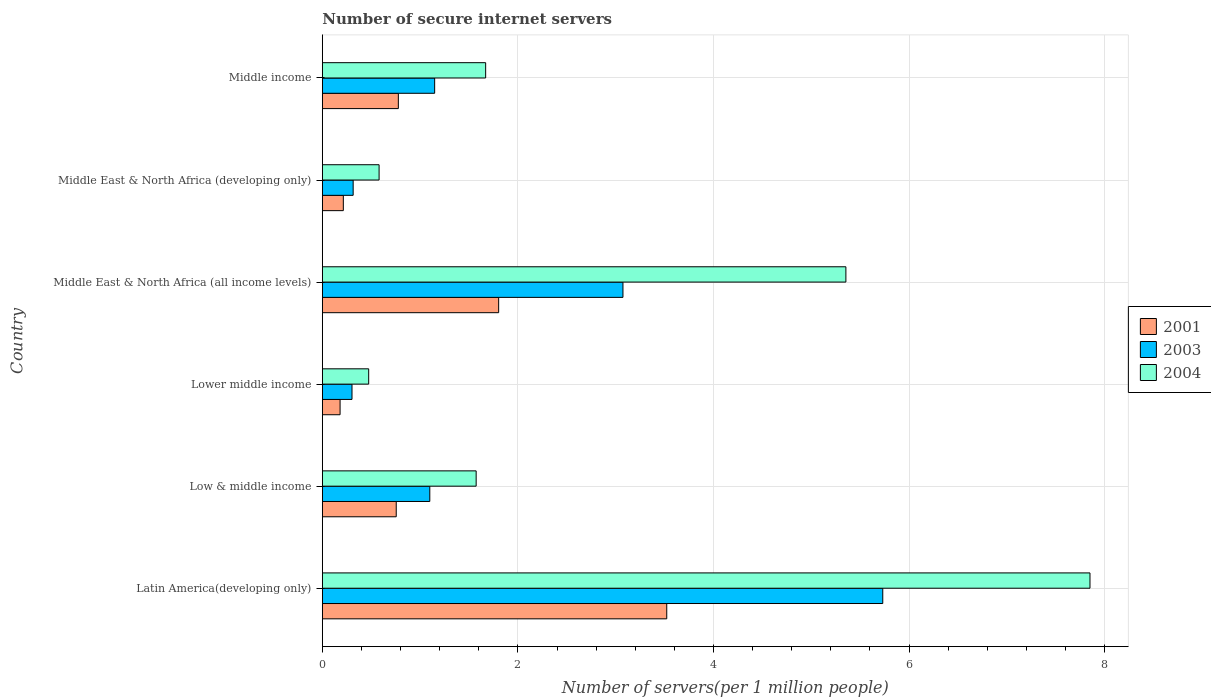How many different coloured bars are there?
Provide a short and direct response. 3. How many groups of bars are there?
Provide a short and direct response. 6. Are the number of bars on each tick of the Y-axis equal?
Offer a terse response. Yes. How many bars are there on the 6th tick from the top?
Provide a short and direct response. 3. How many bars are there on the 5th tick from the bottom?
Provide a short and direct response. 3. What is the label of the 3rd group of bars from the top?
Provide a succinct answer. Middle East & North Africa (all income levels). What is the number of secure internet servers in 2001 in Middle income?
Offer a very short reply. 0.78. Across all countries, what is the maximum number of secure internet servers in 2003?
Provide a succinct answer. 5.73. Across all countries, what is the minimum number of secure internet servers in 2004?
Make the answer very short. 0.47. In which country was the number of secure internet servers in 2001 maximum?
Provide a short and direct response. Latin America(developing only). In which country was the number of secure internet servers in 2004 minimum?
Offer a terse response. Lower middle income. What is the total number of secure internet servers in 2001 in the graph?
Offer a terse response. 7.25. What is the difference between the number of secure internet servers in 2003 in Latin America(developing only) and that in Lower middle income?
Offer a very short reply. 5.43. What is the difference between the number of secure internet servers in 2003 in Middle income and the number of secure internet servers in 2001 in Lower middle income?
Your answer should be very brief. 0.97. What is the average number of secure internet servers in 2004 per country?
Provide a succinct answer. 2.92. What is the difference between the number of secure internet servers in 2004 and number of secure internet servers in 2003 in Middle income?
Offer a very short reply. 0.52. What is the ratio of the number of secure internet servers in 2004 in Latin America(developing only) to that in Middle East & North Africa (developing only)?
Provide a short and direct response. 13.52. Is the number of secure internet servers in 2003 in Middle East & North Africa (all income levels) less than that in Middle income?
Make the answer very short. No. Is the difference between the number of secure internet servers in 2004 in Low & middle income and Middle East & North Africa (developing only) greater than the difference between the number of secure internet servers in 2003 in Low & middle income and Middle East & North Africa (developing only)?
Make the answer very short. Yes. What is the difference between the highest and the second highest number of secure internet servers in 2003?
Your answer should be very brief. 2.66. What is the difference between the highest and the lowest number of secure internet servers in 2001?
Your response must be concise. 3.34. In how many countries, is the number of secure internet servers in 2004 greater than the average number of secure internet servers in 2004 taken over all countries?
Make the answer very short. 2. What does the 2nd bar from the top in Middle East & North Africa (developing only) represents?
Provide a short and direct response. 2003. Is it the case that in every country, the sum of the number of secure internet servers in 2003 and number of secure internet servers in 2001 is greater than the number of secure internet servers in 2004?
Your answer should be compact. No. How many bars are there?
Make the answer very short. 18. What is the difference between two consecutive major ticks on the X-axis?
Your answer should be compact. 2. Does the graph contain any zero values?
Your response must be concise. No. Does the graph contain grids?
Your answer should be compact. Yes. How many legend labels are there?
Your response must be concise. 3. How are the legend labels stacked?
Your response must be concise. Vertical. What is the title of the graph?
Give a very brief answer. Number of secure internet servers. Does "1964" appear as one of the legend labels in the graph?
Give a very brief answer. No. What is the label or title of the X-axis?
Give a very brief answer. Number of servers(per 1 million people). What is the label or title of the Y-axis?
Provide a short and direct response. Country. What is the Number of servers(per 1 million people) in 2001 in Latin America(developing only)?
Make the answer very short. 3.52. What is the Number of servers(per 1 million people) of 2003 in Latin America(developing only)?
Provide a succinct answer. 5.73. What is the Number of servers(per 1 million people) of 2004 in Latin America(developing only)?
Offer a very short reply. 7.85. What is the Number of servers(per 1 million people) in 2001 in Low & middle income?
Keep it short and to the point. 0.76. What is the Number of servers(per 1 million people) in 2003 in Low & middle income?
Give a very brief answer. 1.1. What is the Number of servers(per 1 million people) in 2004 in Low & middle income?
Offer a very short reply. 1.57. What is the Number of servers(per 1 million people) in 2001 in Lower middle income?
Provide a succinct answer. 0.18. What is the Number of servers(per 1 million people) of 2003 in Lower middle income?
Provide a succinct answer. 0.3. What is the Number of servers(per 1 million people) of 2004 in Lower middle income?
Keep it short and to the point. 0.47. What is the Number of servers(per 1 million people) in 2001 in Middle East & North Africa (all income levels)?
Provide a short and direct response. 1.8. What is the Number of servers(per 1 million people) of 2003 in Middle East & North Africa (all income levels)?
Offer a very short reply. 3.07. What is the Number of servers(per 1 million people) of 2004 in Middle East & North Africa (all income levels)?
Ensure brevity in your answer.  5.35. What is the Number of servers(per 1 million people) in 2001 in Middle East & North Africa (developing only)?
Your response must be concise. 0.21. What is the Number of servers(per 1 million people) in 2003 in Middle East & North Africa (developing only)?
Offer a very short reply. 0.32. What is the Number of servers(per 1 million people) of 2004 in Middle East & North Africa (developing only)?
Your answer should be very brief. 0.58. What is the Number of servers(per 1 million people) in 2001 in Middle income?
Make the answer very short. 0.78. What is the Number of servers(per 1 million people) in 2003 in Middle income?
Ensure brevity in your answer.  1.15. What is the Number of servers(per 1 million people) in 2004 in Middle income?
Offer a terse response. 1.67. Across all countries, what is the maximum Number of servers(per 1 million people) in 2001?
Provide a succinct answer. 3.52. Across all countries, what is the maximum Number of servers(per 1 million people) of 2003?
Your answer should be compact. 5.73. Across all countries, what is the maximum Number of servers(per 1 million people) in 2004?
Your answer should be very brief. 7.85. Across all countries, what is the minimum Number of servers(per 1 million people) of 2001?
Give a very brief answer. 0.18. Across all countries, what is the minimum Number of servers(per 1 million people) of 2003?
Provide a short and direct response. 0.3. Across all countries, what is the minimum Number of servers(per 1 million people) of 2004?
Give a very brief answer. 0.47. What is the total Number of servers(per 1 million people) of 2001 in the graph?
Provide a short and direct response. 7.25. What is the total Number of servers(per 1 million people) in 2003 in the graph?
Offer a very short reply. 11.67. What is the total Number of servers(per 1 million people) of 2004 in the graph?
Your answer should be very brief. 17.5. What is the difference between the Number of servers(per 1 million people) in 2001 in Latin America(developing only) and that in Low & middle income?
Ensure brevity in your answer.  2.77. What is the difference between the Number of servers(per 1 million people) in 2003 in Latin America(developing only) and that in Low & middle income?
Your response must be concise. 4.63. What is the difference between the Number of servers(per 1 million people) in 2004 in Latin America(developing only) and that in Low & middle income?
Give a very brief answer. 6.28. What is the difference between the Number of servers(per 1 million people) of 2001 in Latin America(developing only) and that in Lower middle income?
Provide a succinct answer. 3.34. What is the difference between the Number of servers(per 1 million people) of 2003 in Latin America(developing only) and that in Lower middle income?
Provide a short and direct response. 5.43. What is the difference between the Number of servers(per 1 million people) in 2004 in Latin America(developing only) and that in Lower middle income?
Provide a short and direct response. 7.38. What is the difference between the Number of servers(per 1 million people) in 2001 in Latin America(developing only) and that in Middle East & North Africa (all income levels)?
Your answer should be very brief. 1.72. What is the difference between the Number of servers(per 1 million people) of 2003 in Latin America(developing only) and that in Middle East & North Africa (all income levels)?
Give a very brief answer. 2.66. What is the difference between the Number of servers(per 1 million people) of 2004 in Latin America(developing only) and that in Middle East & North Africa (all income levels)?
Ensure brevity in your answer.  2.5. What is the difference between the Number of servers(per 1 million people) of 2001 in Latin America(developing only) and that in Middle East & North Africa (developing only)?
Ensure brevity in your answer.  3.31. What is the difference between the Number of servers(per 1 million people) of 2003 in Latin America(developing only) and that in Middle East & North Africa (developing only)?
Keep it short and to the point. 5.42. What is the difference between the Number of servers(per 1 million people) of 2004 in Latin America(developing only) and that in Middle East & North Africa (developing only)?
Offer a terse response. 7.27. What is the difference between the Number of servers(per 1 million people) in 2001 in Latin America(developing only) and that in Middle income?
Offer a very short reply. 2.75. What is the difference between the Number of servers(per 1 million people) of 2003 in Latin America(developing only) and that in Middle income?
Your answer should be very brief. 4.58. What is the difference between the Number of servers(per 1 million people) of 2004 in Latin America(developing only) and that in Middle income?
Your answer should be very brief. 6.18. What is the difference between the Number of servers(per 1 million people) in 2001 in Low & middle income and that in Lower middle income?
Your answer should be very brief. 0.57. What is the difference between the Number of servers(per 1 million people) of 2003 in Low & middle income and that in Lower middle income?
Ensure brevity in your answer.  0.8. What is the difference between the Number of servers(per 1 million people) in 2004 in Low & middle income and that in Lower middle income?
Ensure brevity in your answer.  1.1. What is the difference between the Number of servers(per 1 million people) of 2001 in Low & middle income and that in Middle East & North Africa (all income levels)?
Your answer should be very brief. -1.05. What is the difference between the Number of servers(per 1 million people) in 2003 in Low & middle income and that in Middle East & North Africa (all income levels)?
Ensure brevity in your answer.  -1.98. What is the difference between the Number of servers(per 1 million people) in 2004 in Low & middle income and that in Middle East & North Africa (all income levels)?
Provide a succinct answer. -3.78. What is the difference between the Number of servers(per 1 million people) of 2001 in Low & middle income and that in Middle East & North Africa (developing only)?
Ensure brevity in your answer.  0.54. What is the difference between the Number of servers(per 1 million people) in 2003 in Low & middle income and that in Middle East & North Africa (developing only)?
Provide a succinct answer. 0.78. What is the difference between the Number of servers(per 1 million people) in 2001 in Low & middle income and that in Middle income?
Ensure brevity in your answer.  -0.02. What is the difference between the Number of servers(per 1 million people) in 2003 in Low & middle income and that in Middle income?
Make the answer very short. -0.05. What is the difference between the Number of servers(per 1 million people) of 2004 in Low & middle income and that in Middle income?
Provide a short and direct response. -0.1. What is the difference between the Number of servers(per 1 million people) of 2001 in Lower middle income and that in Middle East & North Africa (all income levels)?
Offer a very short reply. -1.62. What is the difference between the Number of servers(per 1 million people) of 2003 in Lower middle income and that in Middle East & North Africa (all income levels)?
Offer a very short reply. -2.77. What is the difference between the Number of servers(per 1 million people) in 2004 in Lower middle income and that in Middle East & North Africa (all income levels)?
Ensure brevity in your answer.  -4.88. What is the difference between the Number of servers(per 1 million people) in 2001 in Lower middle income and that in Middle East & North Africa (developing only)?
Provide a short and direct response. -0.03. What is the difference between the Number of servers(per 1 million people) of 2003 in Lower middle income and that in Middle East & North Africa (developing only)?
Offer a very short reply. -0.01. What is the difference between the Number of servers(per 1 million people) of 2004 in Lower middle income and that in Middle East & North Africa (developing only)?
Make the answer very short. -0.11. What is the difference between the Number of servers(per 1 million people) of 2001 in Lower middle income and that in Middle income?
Offer a terse response. -0.6. What is the difference between the Number of servers(per 1 million people) in 2003 in Lower middle income and that in Middle income?
Offer a very short reply. -0.85. What is the difference between the Number of servers(per 1 million people) in 2004 in Lower middle income and that in Middle income?
Your response must be concise. -1.2. What is the difference between the Number of servers(per 1 million people) of 2001 in Middle East & North Africa (all income levels) and that in Middle East & North Africa (developing only)?
Your answer should be very brief. 1.59. What is the difference between the Number of servers(per 1 million people) of 2003 in Middle East & North Africa (all income levels) and that in Middle East & North Africa (developing only)?
Your response must be concise. 2.76. What is the difference between the Number of servers(per 1 million people) of 2004 in Middle East & North Africa (all income levels) and that in Middle East & North Africa (developing only)?
Provide a short and direct response. 4.77. What is the difference between the Number of servers(per 1 million people) of 2001 in Middle East & North Africa (all income levels) and that in Middle income?
Your response must be concise. 1.03. What is the difference between the Number of servers(per 1 million people) in 2003 in Middle East & North Africa (all income levels) and that in Middle income?
Offer a terse response. 1.93. What is the difference between the Number of servers(per 1 million people) in 2004 in Middle East & North Africa (all income levels) and that in Middle income?
Your response must be concise. 3.68. What is the difference between the Number of servers(per 1 million people) of 2001 in Middle East & North Africa (developing only) and that in Middle income?
Make the answer very short. -0.56. What is the difference between the Number of servers(per 1 million people) of 2003 in Middle East & North Africa (developing only) and that in Middle income?
Keep it short and to the point. -0.83. What is the difference between the Number of servers(per 1 million people) of 2004 in Middle East & North Africa (developing only) and that in Middle income?
Ensure brevity in your answer.  -1.09. What is the difference between the Number of servers(per 1 million people) in 2001 in Latin America(developing only) and the Number of servers(per 1 million people) in 2003 in Low & middle income?
Your answer should be very brief. 2.42. What is the difference between the Number of servers(per 1 million people) of 2001 in Latin America(developing only) and the Number of servers(per 1 million people) of 2004 in Low & middle income?
Give a very brief answer. 1.95. What is the difference between the Number of servers(per 1 million people) of 2003 in Latin America(developing only) and the Number of servers(per 1 million people) of 2004 in Low & middle income?
Make the answer very short. 4.16. What is the difference between the Number of servers(per 1 million people) in 2001 in Latin America(developing only) and the Number of servers(per 1 million people) in 2003 in Lower middle income?
Your answer should be very brief. 3.22. What is the difference between the Number of servers(per 1 million people) of 2001 in Latin America(developing only) and the Number of servers(per 1 million people) of 2004 in Lower middle income?
Provide a short and direct response. 3.05. What is the difference between the Number of servers(per 1 million people) of 2003 in Latin America(developing only) and the Number of servers(per 1 million people) of 2004 in Lower middle income?
Ensure brevity in your answer.  5.26. What is the difference between the Number of servers(per 1 million people) in 2001 in Latin America(developing only) and the Number of servers(per 1 million people) in 2003 in Middle East & North Africa (all income levels)?
Your answer should be very brief. 0.45. What is the difference between the Number of servers(per 1 million people) of 2001 in Latin America(developing only) and the Number of servers(per 1 million people) of 2004 in Middle East & North Africa (all income levels)?
Keep it short and to the point. -1.83. What is the difference between the Number of servers(per 1 million people) in 2003 in Latin America(developing only) and the Number of servers(per 1 million people) in 2004 in Middle East & North Africa (all income levels)?
Your answer should be very brief. 0.38. What is the difference between the Number of servers(per 1 million people) in 2001 in Latin America(developing only) and the Number of servers(per 1 million people) in 2003 in Middle East & North Africa (developing only)?
Offer a terse response. 3.21. What is the difference between the Number of servers(per 1 million people) of 2001 in Latin America(developing only) and the Number of servers(per 1 million people) of 2004 in Middle East & North Africa (developing only)?
Provide a succinct answer. 2.94. What is the difference between the Number of servers(per 1 million people) of 2003 in Latin America(developing only) and the Number of servers(per 1 million people) of 2004 in Middle East & North Africa (developing only)?
Keep it short and to the point. 5.15. What is the difference between the Number of servers(per 1 million people) in 2001 in Latin America(developing only) and the Number of servers(per 1 million people) in 2003 in Middle income?
Your answer should be compact. 2.37. What is the difference between the Number of servers(per 1 million people) of 2001 in Latin America(developing only) and the Number of servers(per 1 million people) of 2004 in Middle income?
Offer a very short reply. 1.85. What is the difference between the Number of servers(per 1 million people) of 2003 in Latin America(developing only) and the Number of servers(per 1 million people) of 2004 in Middle income?
Your answer should be compact. 4.06. What is the difference between the Number of servers(per 1 million people) in 2001 in Low & middle income and the Number of servers(per 1 million people) in 2003 in Lower middle income?
Keep it short and to the point. 0.45. What is the difference between the Number of servers(per 1 million people) of 2001 in Low & middle income and the Number of servers(per 1 million people) of 2004 in Lower middle income?
Offer a terse response. 0.28. What is the difference between the Number of servers(per 1 million people) in 2003 in Low & middle income and the Number of servers(per 1 million people) in 2004 in Lower middle income?
Your response must be concise. 0.62. What is the difference between the Number of servers(per 1 million people) in 2001 in Low & middle income and the Number of servers(per 1 million people) in 2003 in Middle East & North Africa (all income levels)?
Keep it short and to the point. -2.32. What is the difference between the Number of servers(per 1 million people) of 2001 in Low & middle income and the Number of servers(per 1 million people) of 2004 in Middle East & North Africa (all income levels)?
Ensure brevity in your answer.  -4.6. What is the difference between the Number of servers(per 1 million people) in 2003 in Low & middle income and the Number of servers(per 1 million people) in 2004 in Middle East & North Africa (all income levels)?
Your answer should be compact. -4.26. What is the difference between the Number of servers(per 1 million people) in 2001 in Low & middle income and the Number of servers(per 1 million people) in 2003 in Middle East & North Africa (developing only)?
Your response must be concise. 0.44. What is the difference between the Number of servers(per 1 million people) of 2001 in Low & middle income and the Number of servers(per 1 million people) of 2004 in Middle East & North Africa (developing only)?
Offer a terse response. 0.18. What is the difference between the Number of servers(per 1 million people) in 2003 in Low & middle income and the Number of servers(per 1 million people) in 2004 in Middle East & North Africa (developing only)?
Your answer should be very brief. 0.52. What is the difference between the Number of servers(per 1 million people) in 2001 in Low & middle income and the Number of servers(per 1 million people) in 2003 in Middle income?
Keep it short and to the point. -0.39. What is the difference between the Number of servers(per 1 million people) in 2001 in Low & middle income and the Number of servers(per 1 million people) in 2004 in Middle income?
Offer a very short reply. -0.91. What is the difference between the Number of servers(per 1 million people) of 2003 in Low & middle income and the Number of servers(per 1 million people) of 2004 in Middle income?
Offer a very short reply. -0.57. What is the difference between the Number of servers(per 1 million people) in 2001 in Lower middle income and the Number of servers(per 1 million people) in 2003 in Middle East & North Africa (all income levels)?
Give a very brief answer. -2.89. What is the difference between the Number of servers(per 1 million people) in 2001 in Lower middle income and the Number of servers(per 1 million people) in 2004 in Middle East & North Africa (all income levels)?
Ensure brevity in your answer.  -5.17. What is the difference between the Number of servers(per 1 million people) in 2003 in Lower middle income and the Number of servers(per 1 million people) in 2004 in Middle East & North Africa (all income levels)?
Offer a terse response. -5.05. What is the difference between the Number of servers(per 1 million people) in 2001 in Lower middle income and the Number of servers(per 1 million people) in 2003 in Middle East & North Africa (developing only)?
Offer a terse response. -0.13. What is the difference between the Number of servers(per 1 million people) of 2001 in Lower middle income and the Number of servers(per 1 million people) of 2004 in Middle East & North Africa (developing only)?
Your answer should be very brief. -0.4. What is the difference between the Number of servers(per 1 million people) in 2003 in Lower middle income and the Number of servers(per 1 million people) in 2004 in Middle East & North Africa (developing only)?
Ensure brevity in your answer.  -0.28. What is the difference between the Number of servers(per 1 million people) of 2001 in Lower middle income and the Number of servers(per 1 million people) of 2003 in Middle income?
Keep it short and to the point. -0.97. What is the difference between the Number of servers(per 1 million people) in 2001 in Lower middle income and the Number of servers(per 1 million people) in 2004 in Middle income?
Ensure brevity in your answer.  -1.49. What is the difference between the Number of servers(per 1 million people) of 2003 in Lower middle income and the Number of servers(per 1 million people) of 2004 in Middle income?
Give a very brief answer. -1.37. What is the difference between the Number of servers(per 1 million people) in 2001 in Middle East & North Africa (all income levels) and the Number of servers(per 1 million people) in 2003 in Middle East & North Africa (developing only)?
Offer a terse response. 1.49. What is the difference between the Number of servers(per 1 million people) in 2001 in Middle East & North Africa (all income levels) and the Number of servers(per 1 million people) in 2004 in Middle East & North Africa (developing only)?
Provide a short and direct response. 1.22. What is the difference between the Number of servers(per 1 million people) of 2003 in Middle East & North Africa (all income levels) and the Number of servers(per 1 million people) of 2004 in Middle East & North Africa (developing only)?
Offer a very short reply. 2.49. What is the difference between the Number of servers(per 1 million people) of 2001 in Middle East & North Africa (all income levels) and the Number of servers(per 1 million people) of 2003 in Middle income?
Offer a very short reply. 0.65. What is the difference between the Number of servers(per 1 million people) of 2001 in Middle East & North Africa (all income levels) and the Number of servers(per 1 million people) of 2004 in Middle income?
Keep it short and to the point. 0.13. What is the difference between the Number of servers(per 1 million people) of 2003 in Middle East & North Africa (all income levels) and the Number of servers(per 1 million people) of 2004 in Middle income?
Your answer should be very brief. 1.4. What is the difference between the Number of servers(per 1 million people) of 2001 in Middle East & North Africa (developing only) and the Number of servers(per 1 million people) of 2003 in Middle income?
Keep it short and to the point. -0.93. What is the difference between the Number of servers(per 1 million people) in 2001 in Middle East & North Africa (developing only) and the Number of servers(per 1 million people) in 2004 in Middle income?
Your answer should be compact. -1.46. What is the difference between the Number of servers(per 1 million people) of 2003 in Middle East & North Africa (developing only) and the Number of servers(per 1 million people) of 2004 in Middle income?
Ensure brevity in your answer.  -1.35. What is the average Number of servers(per 1 million people) of 2001 per country?
Offer a terse response. 1.21. What is the average Number of servers(per 1 million people) in 2003 per country?
Your answer should be very brief. 1.95. What is the average Number of servers(per 1 million people) in 2004 per country?
Your answer should be very brief. 2.92. What is the difference between the Number of servers(per 1 million people) in 2001 and Number of servers(per 1 million people) in 2003 in Latin America(developing only)?
Give a very brief answer. -2.21. What is the difference between the Number of servers(per 1 million people) in 2001 and Number of servers(per 1 million people) in 2004 in Latin America(developing only)?
Provide a short and direct response. -4.33. What is the difference between the Number of servers(per 1 million people) in 2003 and Number of servers(per 1 million people) in 2004 in Latin America(developing only)?
Make the answer very short. -2.12. What is the difference between the Number of servers(per 1 million people) of 2001 and Number of servers(per 1 million people) of 2003 in Low & middle income?
Offer a terse response. -0.34. What is the difference between the Number of servers(per 1 million people) in 2001 and Number of servers(per 1 million people) in 2004 in Low & middle income?
Give a very brief answer. -0.82. What is the difference between the Number of servers(per 1 million people) in 2003 and Number of servers(per 1 million people) in 2004 in Low & middle income?
Provide a short and direct response. -0.47. What is the difference between the Number of servers(per 1 million people) of 2001 and Number of servers(per 1 million people) of 2003 in Lower middle income?
Offer a very short reply. -0.12. What is the difference between the Number of servers(per 1 million people) in 2001 and Number of servers(per 1 million people) in 2004 in Lower middle income?
Offer a terse response. -0.29. What is the difference between the Number of servers(per 1 million people) in 2003 and Number of servers(per 1 million people) in 2004 in Lower middle income?
Offer a terse response. -0.17. What is the difference between the Number of servers(per 1 million people) of 2001 and Number of servers(per 1 million people) of 2003 in Middle East & North Africa (all income levels)?
Offer a very short reply. -1.27. What is the difference between the Number of servers(per 1 million people) of 2001 and Number of servers(per 1 million people) of 2004 in Middle East & North Africa (all income levels)?
Offer a very short reply. -3.55. What is the difference between the Number of servers(per 1 million people) in 2003 and Number of servers(per 1 million people) in 2004 in Middle East & North Africa (all income levels)?
Ensure brevity in your answer.  -2.28. What is the difference between the Number of servers(per 1 million people) in 2001 and Number of servers(per 1 million people) in 2003 in Middle East & North Africa (developing only)?
Offer a terse response. -0.1. What is the difference between the Number of servers(per 1 million people) of 2001 and Number of servers(per 1 million people) of 2004 in Middle East & North Africa (developing only)?
Give a very brief answer. -0.37. What is the difference between the Number of servers(per 1 million people) in 2003 and Number of servers(per 1 million people) in 2004 in Middle East & North Africa (developing only)?
Give a very brief answer. -0.27. What is the difference between the Number of servers(per 1 million people) in 2001 and Number of servers(per 1 million people) in 2003 in Middle income?
Your response must be concise. -0.37. What is the difference between the Number of servers(per 1 million people) of 2001 and Number of servers(per 1 million people) of 2004 in Middle income?
Your response must be concise. -0.89. What is the difference between the Number of servers(per 1 million people) in 2003 and Number of servers(per 1 million people) in 2004 in Middle income?
Provide a succinct answer. -0.52. What is the ratio of the Number of servers(per 1 million people) in 2001 in Latin America(developing only) to that in Low & middle income?
Your answer should be compact. 4.66. What is the ratio of the Number of servers(per 1 million people) of 2003 in Latin America(developing only) to that in Low & middle income?
Offer a very short reply. 5.21. What is the ratio of the Number of servers(per 1 million people) in 2004 in Latin America(developing only) to that in Low & middle income?
Give a very brief answer. 4.99. What is the ratio of the Number of servers(per 1 million people) of 2001 in Latin America(developing only) to that in Lower middle income?
Your answer should be very brief. 19.4. What is the ratio of the Number of servers(per 1 million people) in 2003 in Latin America(developing only) to that in Lower middle income?
Provide a short and direct response. 18.89. What is the ratio of the Number of servers(per 1 million people) of 2004 in Latin America(developing only) to that in Lower middle income?
Provide a succinct answer. 16.56. What is the ratio of the Number of servers(per 1 million people) in 2001 in Latin America(developing only) to that in Middle East & North Africa (all income levels)?
Provide a succinct answer. 1.95. What is the ratio of the Number of servers(per 1 million people) in 2003 in Latin America(developing only) to that in Middle East & North Africa (all income levels)?
Offer a terse response. 1.86. What is the ratio of the Number of servers(per 1 million people) of 2004 in Latin America(developing only) to that in Middle East & North Africa (all income levels)?
Make the answer very short. 1.47. What is the ratio of the Number of servers(per 1 million people) of 2001 in Latin America(developing only) to that in Middle East & North Africa (developing only)?
Your response must be concise. 16.41. What is the ratio of the Number of servers(per 1 million people) of 2003 in Latin America(developing only) to that in Middle East & North Africa (developing only)?
Provide a short and direct response. 18.18. What is the ratio of the Number of servers(per 1 million people) in 2004 in Latin America(developing only) to that in Middle East & North Africa (developing only)?
Your answer should be very brief. 13.52. What is the ratio of the Number of servers(per 1 million people) of 2001 in Latin America(developing only) to that in Middle income?
Your response must be concise. 4.53. What is the ratio of the Number of servers(per 1 million people) of 2003 in Latin America(developing only) to that in Middle income?
Keep it short and to the point. 4.99. What is the ratio of the Number of servers(per 1 million people) in 2004 in Latin America(developing only) to that in Middle income?
Provide a succinct answer. 4.7. What is the ratio of the Number of servers(per 1 million people) of 2001 in Low & middle income to that in Lower middle income?
Make the answer very short. 4.16. What is the ratio of the Number of servers(per 1 million people) in 2003 in Low & middle income to that in Lower middle income?
Your answer should be compact. 3.62. What is the ratio of the Number of servers(per 1 million people) in 2004 in Low & middle income to that in Lower middle income?
Offer a terse response. 3.32. What is the ratio of the Number of servers(per 1 million people) of 2001 in Low & middle income to that in Middle East & North Africa (all income levels)?
Your response must be concise. 0.42. What is the ratio of the Number of servers(per 1 million people) in 2003 in Low & middle income to that in Middle East & North Africa (all income levels)?
Your answer should be very brief. 0.36. What is the ratio of the Number of servers(per 1 million people) of 2004 in Low & middle income to that in Middle East & North Africa (all income levels)?
Ensure brevity in your answer.  0.29. What is the ratio of the Number of servers(per 1 million people) in 2001 in Low & middle income to that in Middle East & North Africa (developing only)?
Give a very brief answer. 3.52. What is the ratio of the Number of servers(per 1 million people) in 2003 in Low & middle income to that in Middle East & North Africa (developing only)?
Ensure brevity in your answer.  3.49. What is the ratio of the Number of servers(per 1 million people) in 2004 in Low & middle income to that in Middle East & North Africa (developing only)?
Your answer should be compact. 2.71. What is the ratio of the Number of servers(per 1 million people) in 2001 in Low & middle income to that in Middle income?
Your answer should be compact. 0.97. What is the ratio of the Number of servers(per 1 million people) in 2003 in Low & middle income to that in Middle income?
Offer a very short reply. 0.96. What is the ratio of the Number of servers(per 1 million people) of 2004 in Low & middle income to that in Middle income?
Offer a very short reply. 0.94. What is the ratio of the Number of servers(per 1 million people) in 2001 in Lower middle income to that in Middle East & North Africa (all income levels)?
Give a very brief answer. 0.1. What is the ratio of the Number of servers(per 1 million people) in 2003 in Lower middle income to that in Middle East & North Africa (all income levels)?
Your answer should be compact. 0.1. What is the ratio of the Number of servers(per 1 million people) in 2004 in Lower middle income to that in Middle East & North Africa (all income levels)?
Offer a very short reply. 0.09. What is the ratio of the Number of servers(per 1 million people) in 2001 in Lower middle income to that in Middle East & North Africa (developing only)?
Keep it short and to the point. 0.85. What is the ratio of the Number of servers(per 1 million people) of 2003 in Lower middle income to that in Middle East & North Africa (developing only)?
Offer a very short reply. 0.96. What is the ratio of the Number of servers(per 1 million people) in 2004 in Lower middle income to that in Middle East & North Africa (developing only)?
Provide a succinct answer. 0.82. What is the ratio of the Number of servers(per 1 million people) of 2001 in Lower middle income to that in Middle income?
Provide a short and direct response. 0.23. What is the ratio of the Number of servers(per 1 million people) in 2003 in Lower middle income to that in Middle income?
Your response must be concise. 0.26. What is the ratio of the Number of servers(per 1 million people) in 2004 in Lower middle income to that in Middle income?
Your answer should be compact. 0.28. What is the ratio of the Number of servers(per 1 million people) of 2001 in Middle East & North Africa (all income levels) to that in Middle East & North Africa (developing only)?
Provide a short and direct response. 8.4. What is the ratio of the Number of servers(per 1 million people) in 2003 in Middle East & North Africa (all income levels) to that in Middle East & North Africa (developing only)?
Offer a terse response. 9.75. What is the ratio of the Number of servers(per 1 million people) in 2004 in Middle East & North Africa (all income levels) to that in Middle East & North Africa (developing only)?
Your response must be concise. 9.22. What is the ratio of the Number of servers(per 1 million people) in 2001 in Middle East & North Africa (all income levels) to that in Middle income?
Provide a short and direct response. 2.32. What is the ratio of the Number of servers(per 1 million people) in 2003 in Middle East & North Africa (all income levels) to that in Middle income?
Ensure brevity in your answer.  2.68. What is the ratio of the Number of servers(per 1 million people) of 2004 in Middle East & North Africa (all income levels) to that in Middle income?
Keep it short and to the point. 3.21. What is the ratio of the Number of servers(per 1 million people) in 2001 in Middle East & North Africa (developing only) to that in Middle income?
Offer a very short reply. 0.28. What is the ratio of the Number of servers(per 1 million people) of 2003 in Middle East & North Africa (developing only) to that in Middle income?
Offer a terse response. 0.27. What is the ratio of the Number of servers(per 1 million people) in 2004 in Middle East & North Africa (developing only) to that in Middle income?
Give a very brief answer. 0.35. What is the difference between the highest and the second highest Number of servers(per 1 million people) in 2001?
Give a very brief answer. 1.72. What is the difference between the highest and the second highest Number of servers(per 1 million people) in 2003?
Keep it short and to the point. 2.66. What is the difference between the highest and the second highest Number of servers(per 1 million people) in 2004?
Keep it short and to the point. 2.5. What is the difference between the highest and the lowest Number of servers(per 1 million people) in 2001?
Provide a short and direct response. 3.34. What is the difference between the highest and the lowest Number of servers(per 1 million people) in 2003?
Provide a succinct answer. 5.43. What is the difference between the highest and the lowest Number of servers(per 1 million people) of 2004?
Offer a terse response. 7.38. 